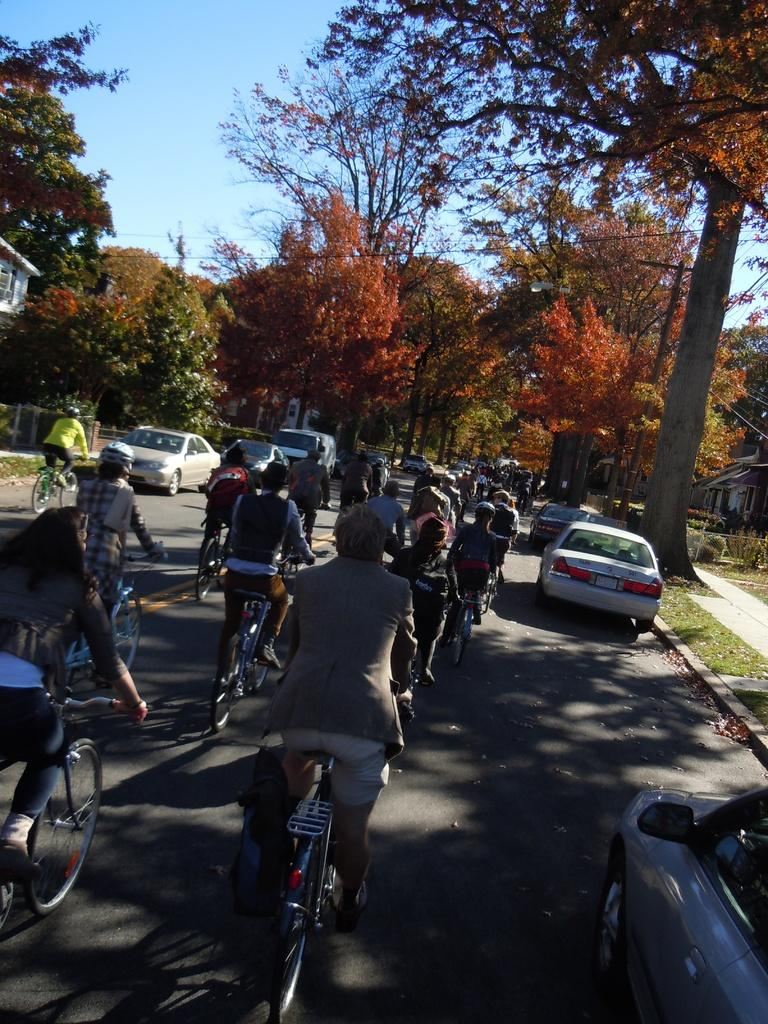What activity are the people in the image engaged in? The people in the image are cycling on a road. What else can be seen on the road in the image? There are vehicles in the image. What can be seen in the background of the image? There are trees and the sky visible in the background. What type of letters are being delivered by the hospital in the image? There is no hospital or delivery of letters present in the image. What color are the lips of the person cycling in the image? There is no visible person's lips in the image. 